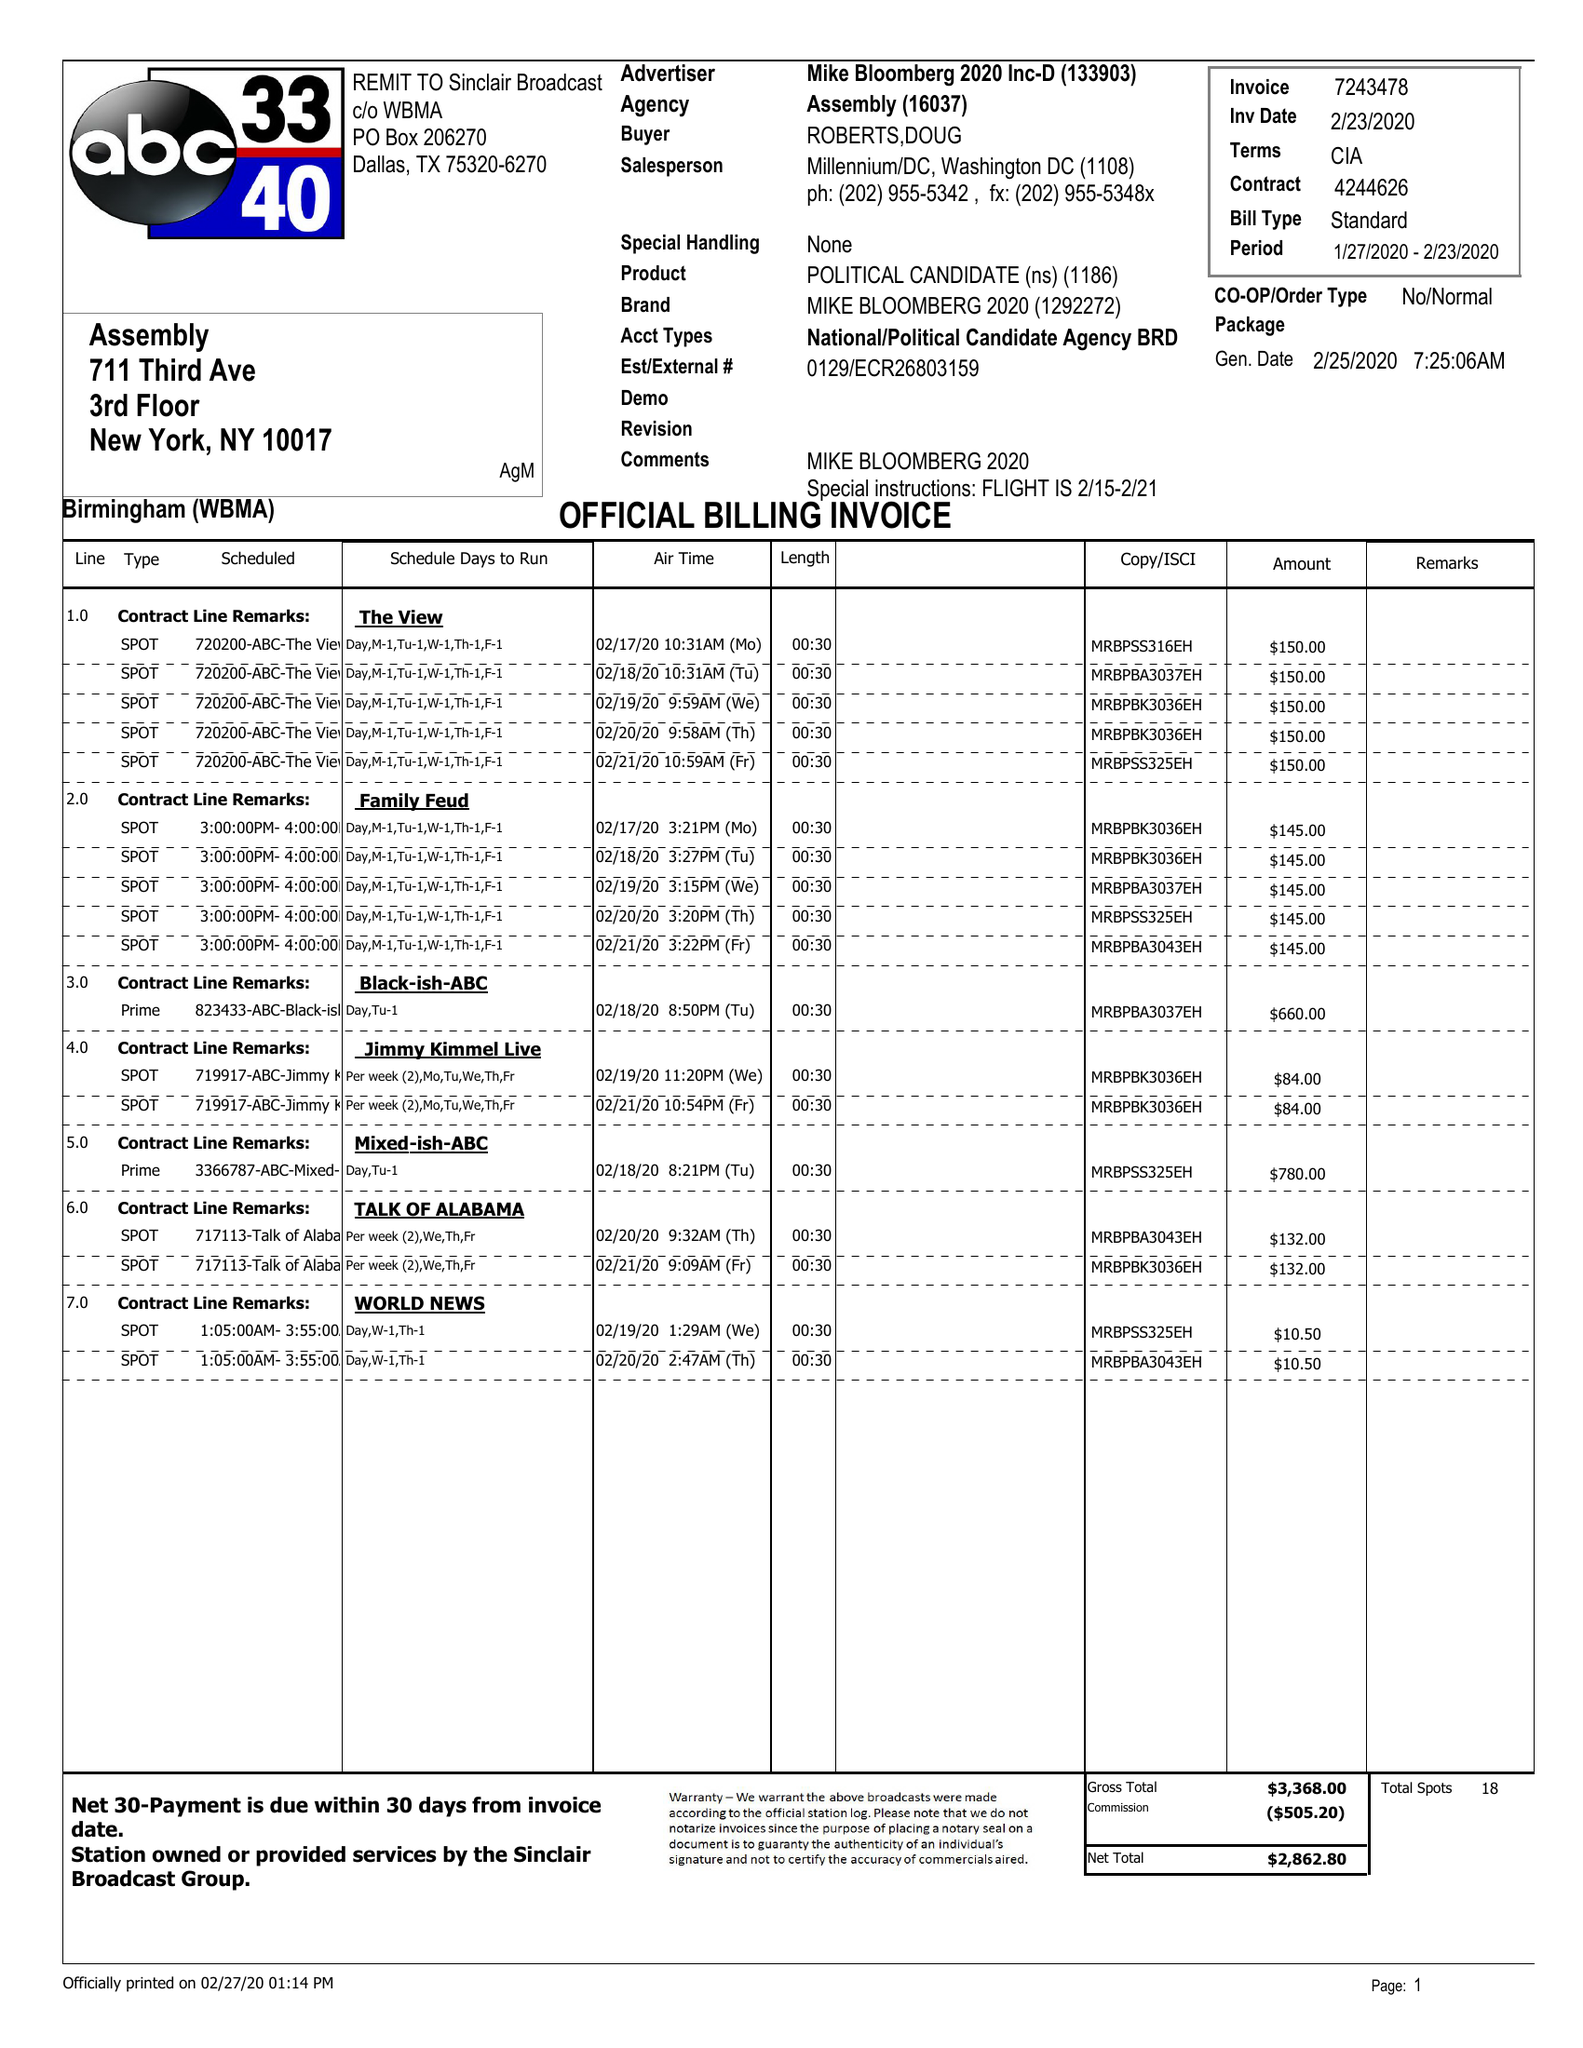What is the value for the flight_from?
Answer the question using a single word or phrase. 01/27/20 